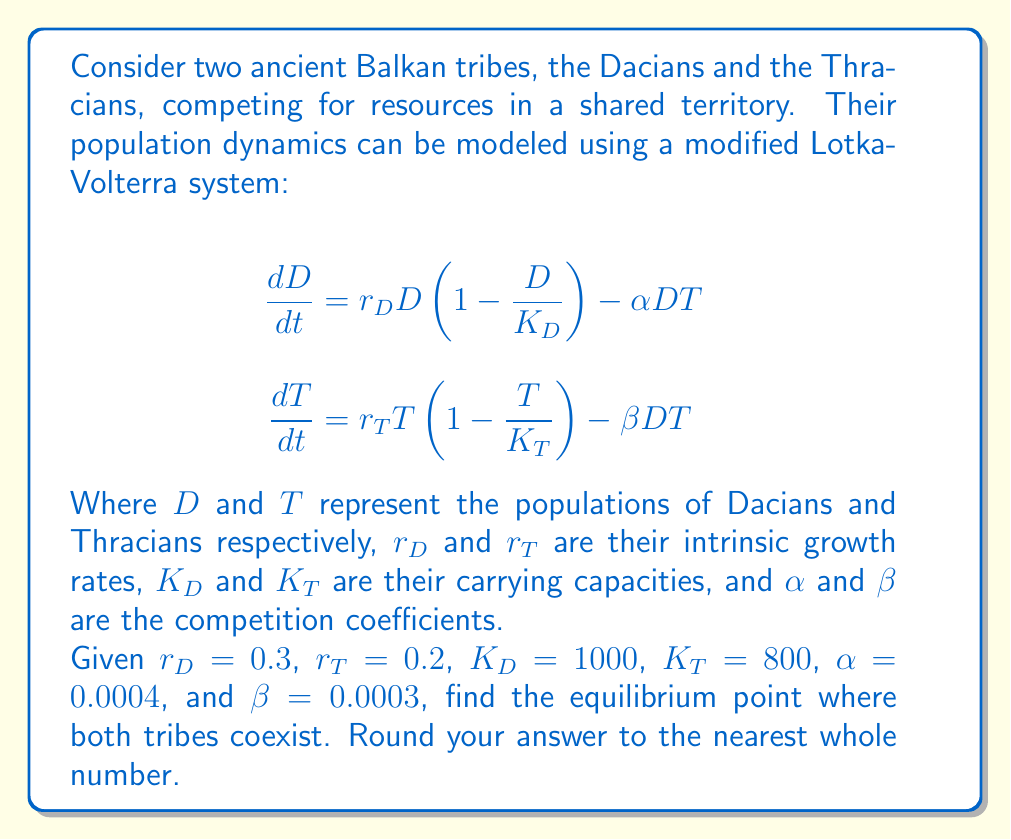Help me with this question. To find the equilibrium point, we need to set both equations equal to zero and solve for $D$ and $T$:

1) Set equations to zero:
   $$0 = r_D D \left(1 - \frac{D}{K_D}\right) - \alpha DT$$
   $$0 = r_T T \left(1 - \frac{T}{K_T}\right) - \beta DT$$

2) Factor out $D$ and $T$ respectively:
   $$0 = D \left[r_D \left(1 - \frac{D}{K_D}\right) - \alpha T\right]$$
   $$0 = T \left[r_T \left(1 - \frac{T}{K_T}\right) - \beta D\right]$$

3) For coexistence, both $D$ and $T$ must be non-zero, so we set the terms in brackets to zero:
   $$r_D \left(1 - \frac{D}{K_D}\right) - \alpha T = 0$$
   $$r_T \left(1 - \frac{T}{K_T}\right) - \beta D = 0$$

4) Solve these equations for $D$ and $T$:
   $$D = K_D \left(1 - \frac{\alpha T}{r_D}\right)$$
   $$T = K_T \left(1 - \frac{\beta D}{r_T}\right)$$

5) Substitute the given values:
   $$D = 1000 \left(1 - \frac{0.0004 T}{0.3}\right)$$
   $$T = 800 \left(1 - \frac{0.0003 D}{0.2}\right)$$

6) Simplify:
   $$D = 1000 - \frac{4}{3}T$$
   $$T = 800 - 1.2D$$

7) Substitute the second equation into the first:
   $$D = 1000 - \frac{4}{3}(800 - 1.2D)$$
   $$D = 1000 - 1066.67 + 1.6D$$
   $$-0.6D = -66.67$$
   $$D = 111.11$$

8) Substitute this value of $D$ back into the equation for $T$:
   $$T = 800 - 1.2(111.11) = 666.67$$

9) Rounding to the nearest whole number:
   $D = 111$ and $T = 667$
Answer: (111, 667) 